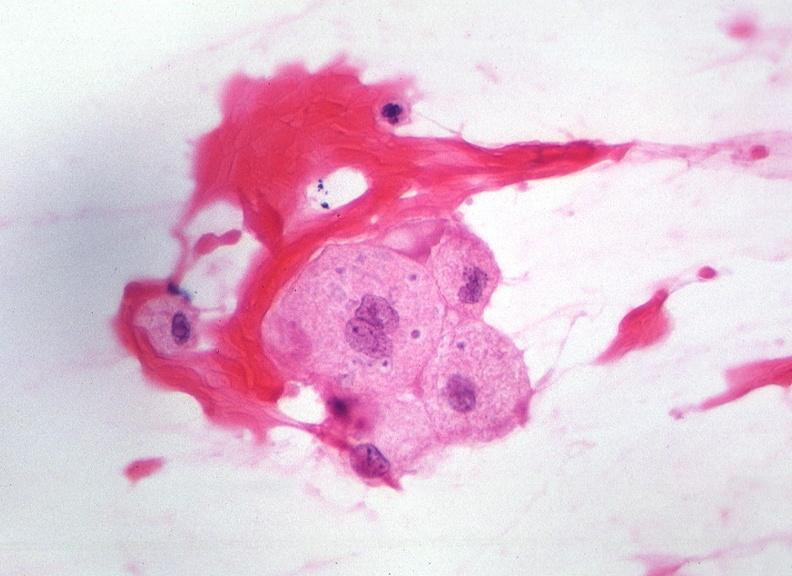does this image show touch impression from cerebrospinal fluid - toxoplasma?
Answer the question using a single word or phrase. Yes 